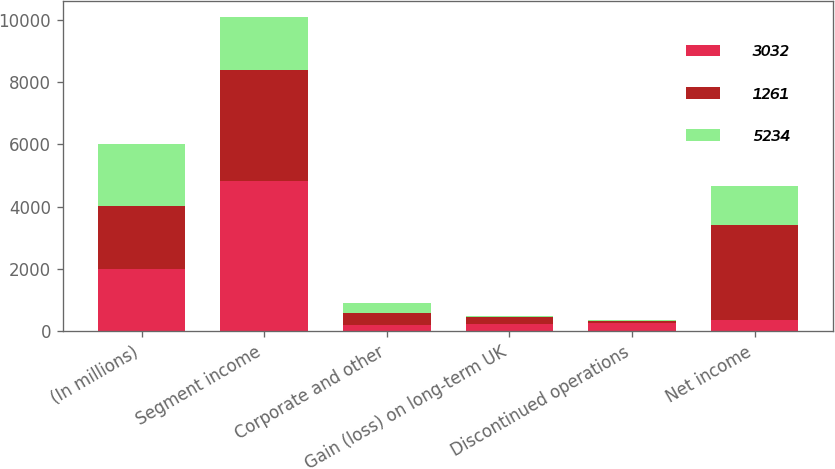Convert chart to OTSL. <chart><loc_0><loc_0><loc_500><loc_500><stacked_bar_chart><ecel><fcel>(In millions)<fcel>Segment income<fcel>Corporate and other<fcel>Gain (loss) on long-term UK<fcel>Discontinued operations<fcel>Net income<nl><fcel>3032<fcel>2006<fcel>4814<fcel>212<fcel>232<fcel>277<fcel>377<nl><fcel>1261<fcel>2005<fcel>3570<fcel>377<fcel>223<fcel>45<fcel>3032<nl><fcel>5234<fcel>2004<fcel>1695<fcel>327<fcel>57<fcel>33<fcel>1261<nl></chart> 